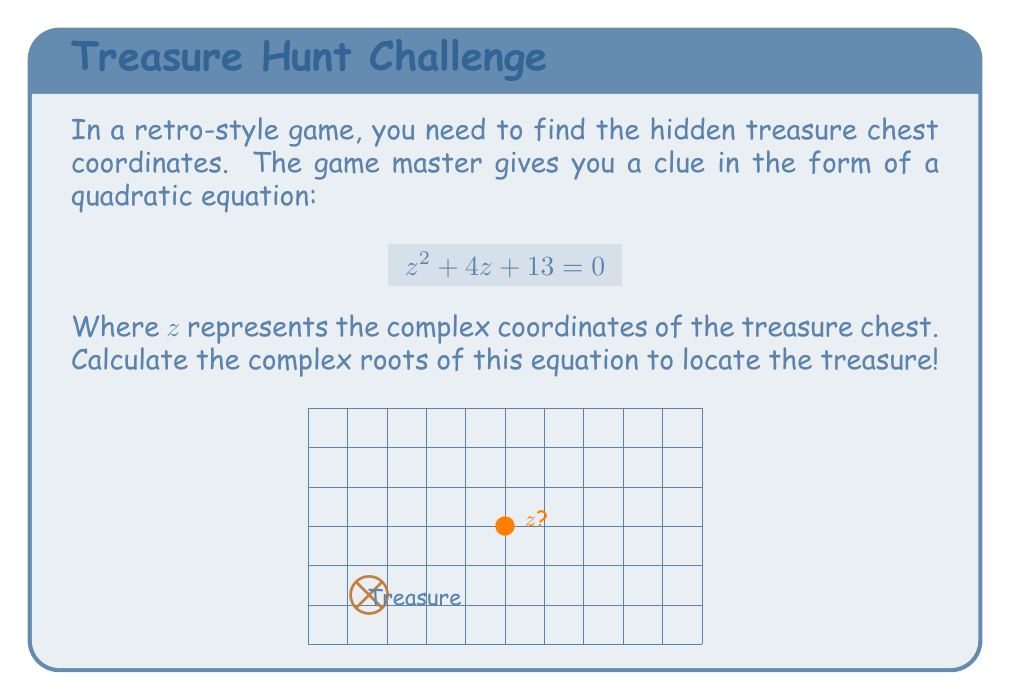Show me your answer to this math problem. Let's solve this step-by-step using the quadratic formula:

1) The quadratic formula for $az^2 + bz + c = 0$ is:

   $$z = \frac{-b \pm \sqrt{b^2 - 4ac}}{2a}$$

2) In our case, $a=1$, $b=4$, and $c=13$

3) Substituting these values:

   $$z = \frac{-4 \pm \sqrt{4^2 - 4(1)(13)}}{2(1)}$$

4) Simplify under the square root:

   $$z = \frac{-4 \pm \sqrt{16 - 52}}{2} = \frac{-4 \pm \sqrt{-36}}{2}$$

5) Simplify $\sqrt{-36}$:

   $$z = \frac{-4 \pm 6i}{2}$$

6) Separate the real and imaginary parts:

   $$z = -2 \pm 3i$$

Therefore, the two complex roots are:

$z_1 = -2 + 3i$ and $z_2 = -2 - 3i$
Answer: $z = -2 \pm 3i$ 